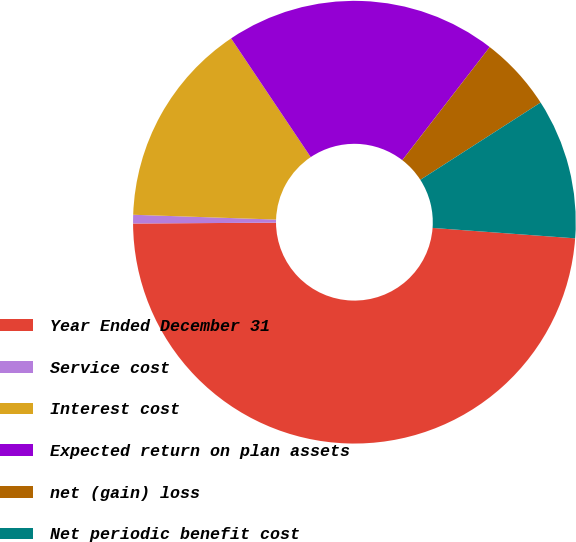Convert chart. <chart><loc_0><loc_0><loc_500><loc_500><pie_chart><fcel>Year Ended December 31<fcel>Service cost<fcel>Interest cost<fcel>Expected return on plan assets<fcel>net (gain) loss<fcel>Net periodic benefit cost<nl><fcel>48.74%<fcel>0.63%<fcel>15.06%<fcel>19.87%<fcel>5.44%<fcel>10.25%<nl></chart> 